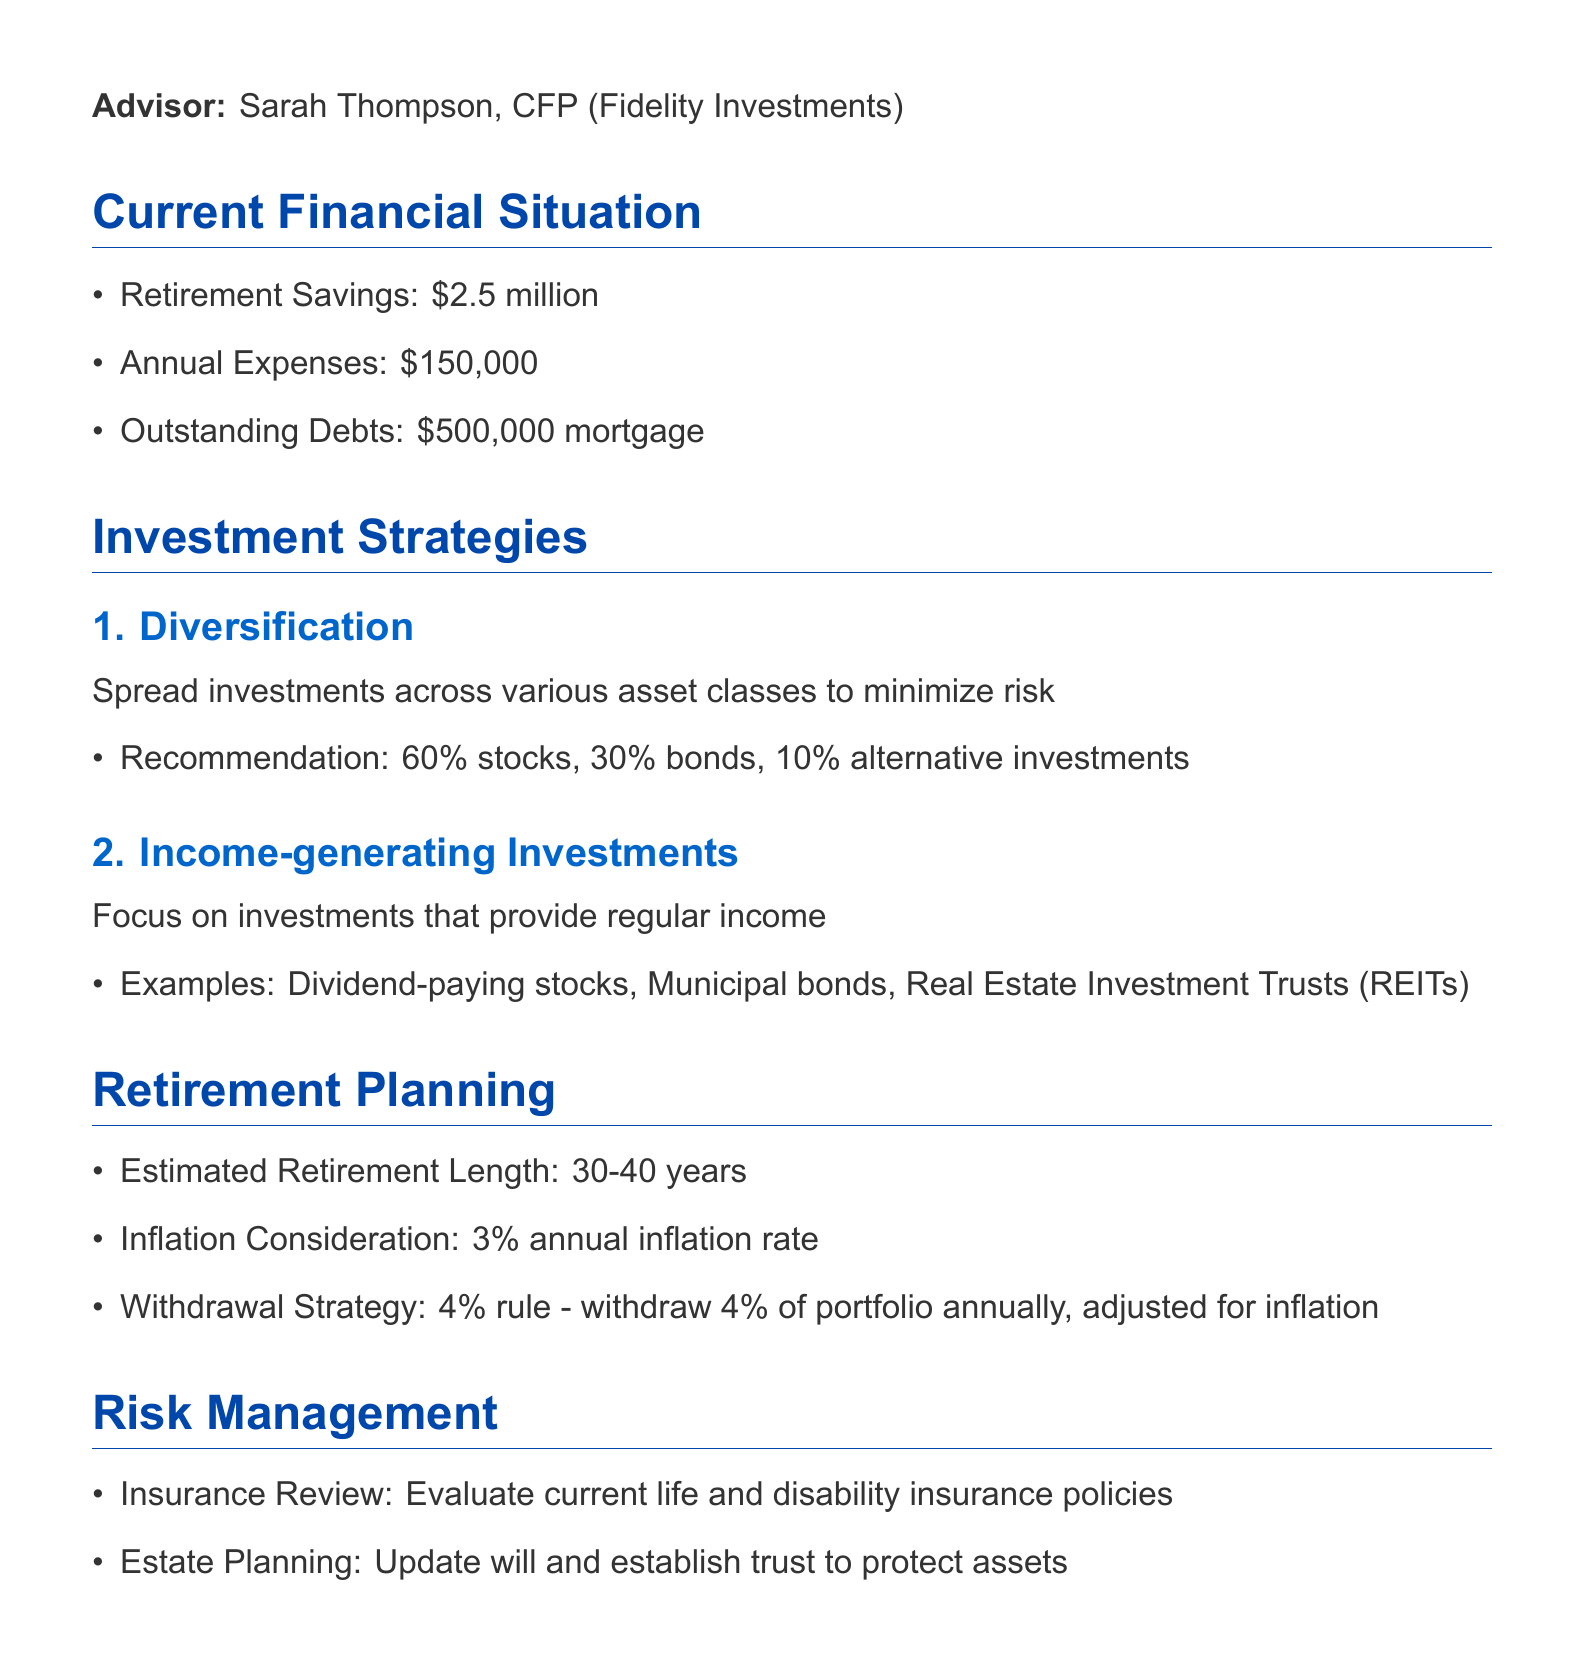What is the name of the financial advisor? The financial advisor's name is listed in the meeting details section.
Answer: Sarah Thompson, CFP What is the total amount of retirement savings? The total retirement savings is stated directly in the current financial situation section.
Answer: $2.5 million What is the recommended stock allocation percentage? The recommended stock allocation is part of the diversification strategy mentioned in the investment strategies section.
Answer: 60% What is the estimated retirement length? The estimated retirement length is provided in the retirement planning section.
Answer: 30-40 years What is the withdrawal strategy indicated in the document? The withdrawal strategy is mentioned in the retirement planning section and follows a specific rule.
Answer: 4% rule What type of investments should be focused on for generating income? The document lists specific examples within the income-generating investments strategy in the investment strategies section.
Answer: Dividend-paying stocks What should be evaluated during the insurance review? The specific focus for evaluating insurance is mentioned under the risk management section.
Answer: Life and disability insurance policies What is the annual inflation consideration? The inflation consideration is noted in the retirement planning section.
Answer: 3% annual inflation rate What is one of the next steps in the financial plan? The next steps are detailed in the last section of the document, focusing on actions to take.
Answer: Conduct thorough review of current investment portfolio 